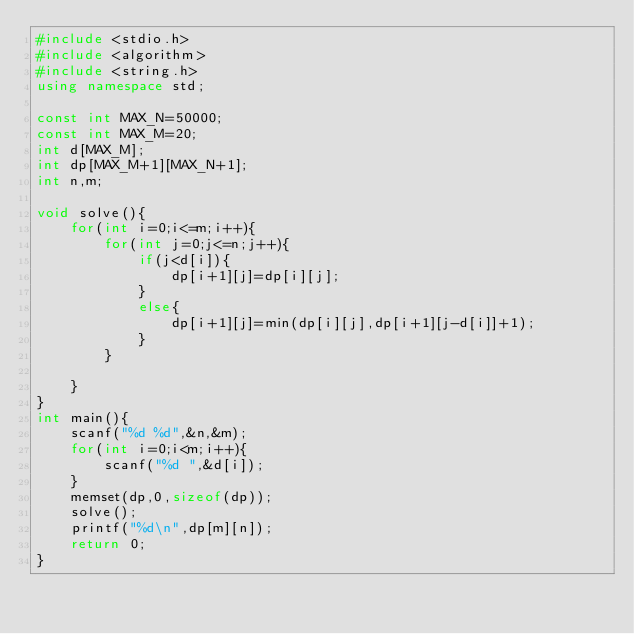Convert code to text. <code><loc_0><loc_0><loc_500><loc_500><_C++_>#include <stdio.h>
#include <algorithm>
#include <string.h>
using namespace std;

const int MAX_N=50000;
const int MAX_M=20;
int d[MAX_M];
int dp[MAX_M+1][MAX_N+1];
int n,m;

void solve(){
	for(int i=0;i<=m;i++){
		for(int j=0;j<=n;j++){
			if(j<d[i]){
				dp[i+1][j]=dp[i][j];
			}
			else{
				dp[i+1][j]=min(dp[i][j],dp[i+1][j-d[i]]+1);
			}
		}

	}
}
int main(){
	scanf("%d %d",&n,&m);
	for(int i=0;i<m;i++){
		scanf("%d ",&d[i]);
	}
	memset(dp,0,sizeof(dp));
	solve();
	printf("%d\n",dp[m][n]);
	return 0;
}</code> 